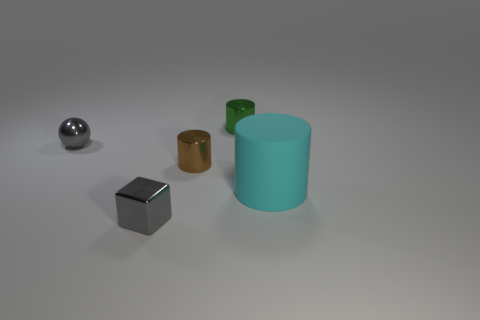What is the material of the large cyan object that is the same shape as the small brown thing? rubber 